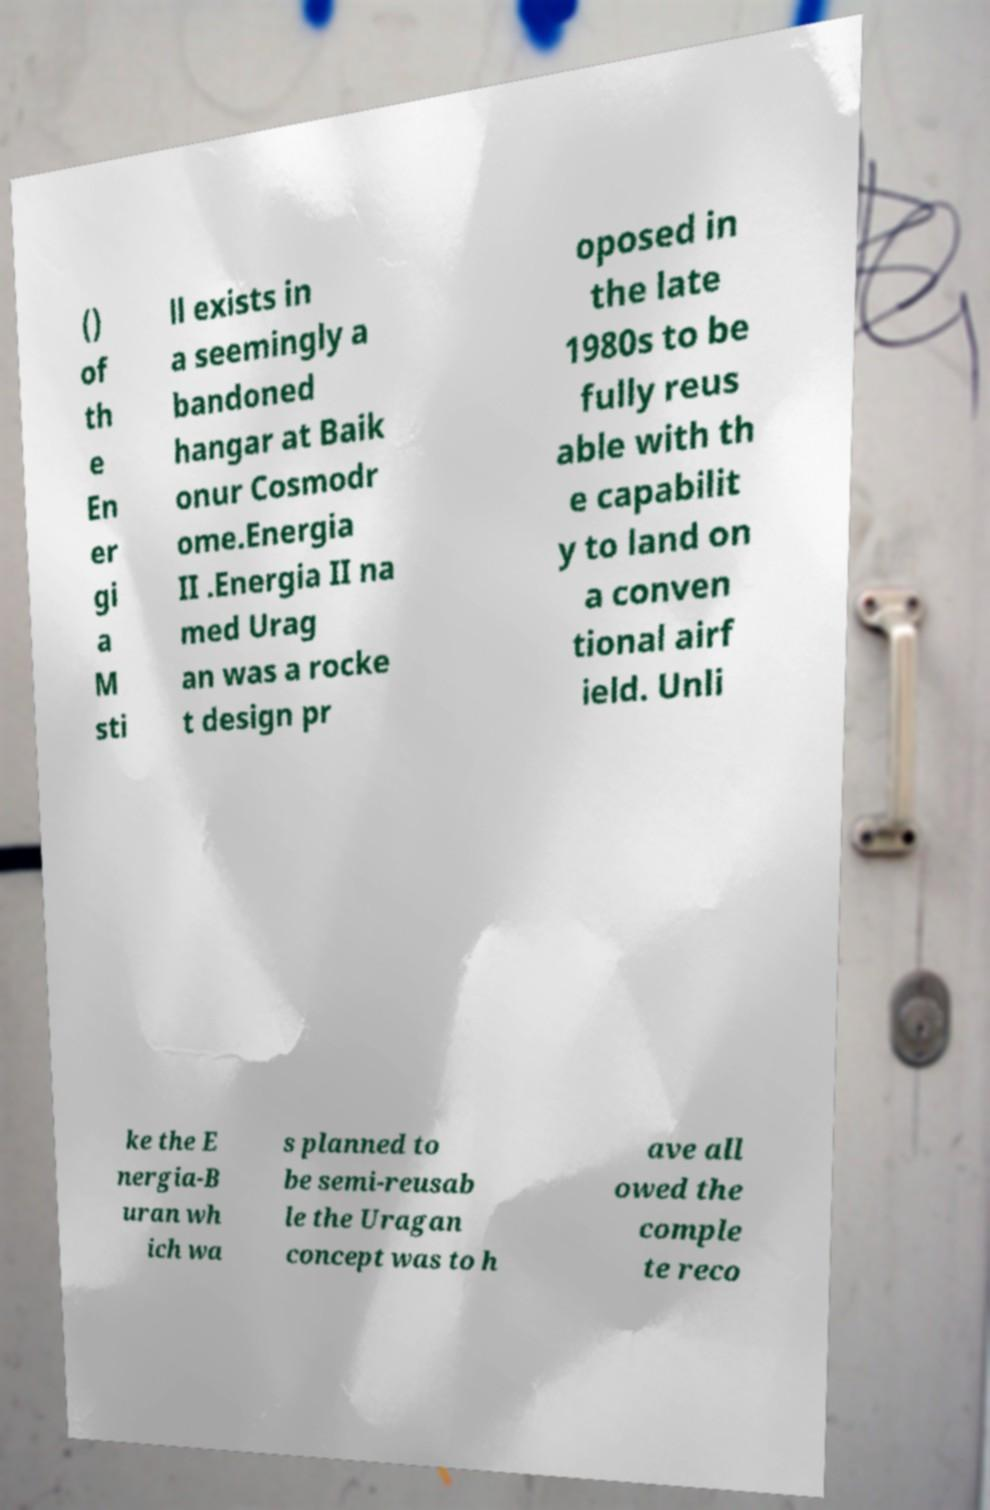What messages or text are displayed in this image? I need them in a readable, typed format. () of th e En er gi a M sti ll exists in a seemingly a bandoned hangar at Baik onur Cosmodr ome.Energia II .Energia II na med Urag an was a rocke t design pr oposed in the late 1980s to be fully reus able with th e capabilit y to land on a conven tional airf ield. Unli ke the E nergia-B uran wh ich wa s planned to be semi-reusab le the Uragan concept was to h ave all owed the comple te reco 